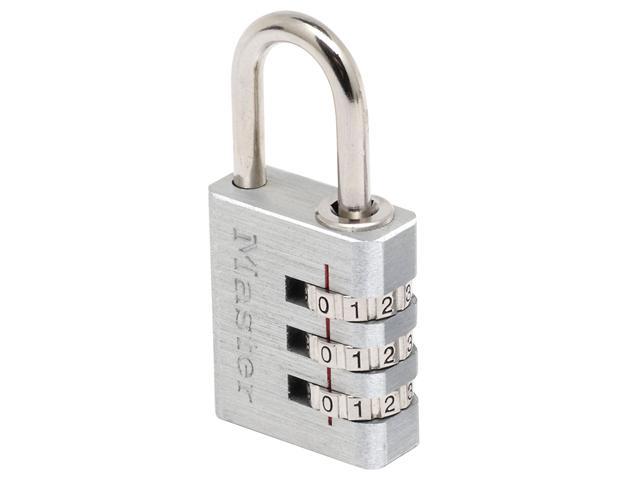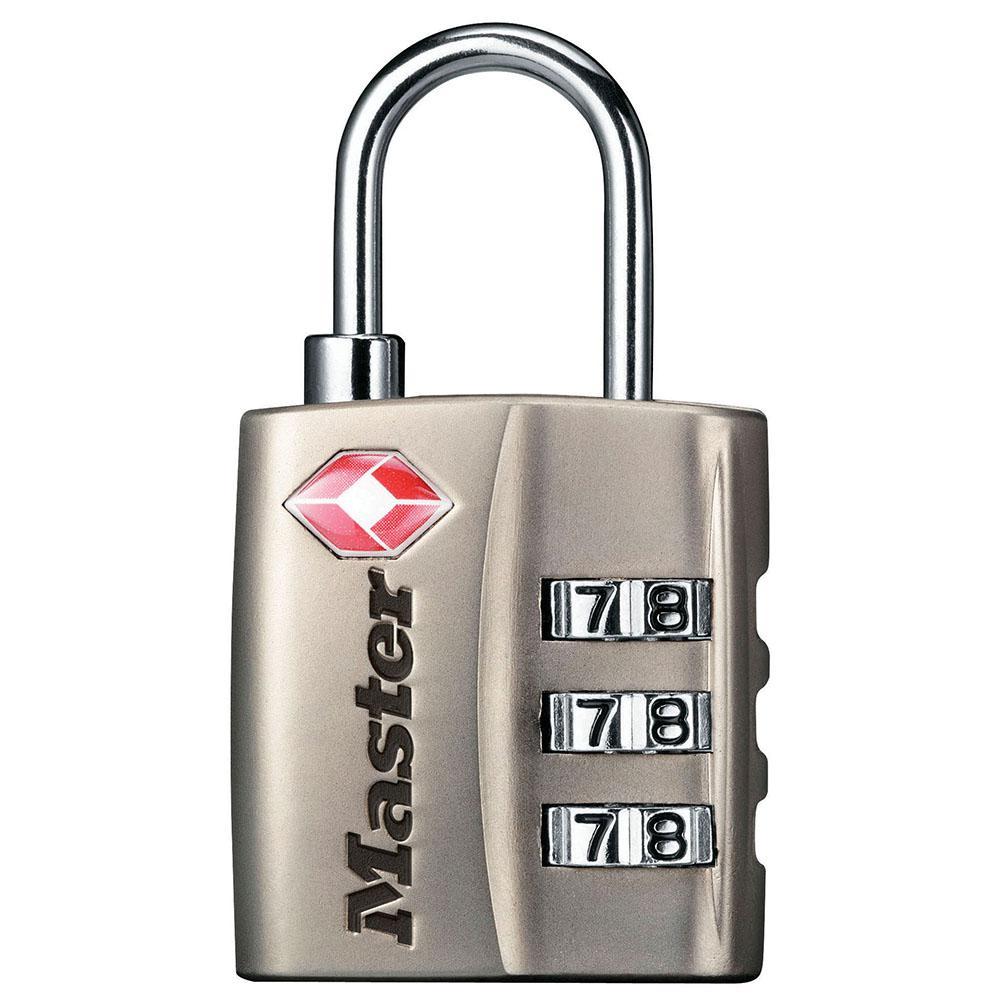The first image is the image on the left, the second image is the image on the right. For the images displayed, is the sentence "Only one of the locks are mostly black in color." factually correct? Answer yes or no. No. The first image is the image on the left, the second image is the image on the right. For the images displayed, is the sentence "Images contain a total of at least two rectangular silver-colored combination locks." factually correct? Answer yes or no. Yes. 